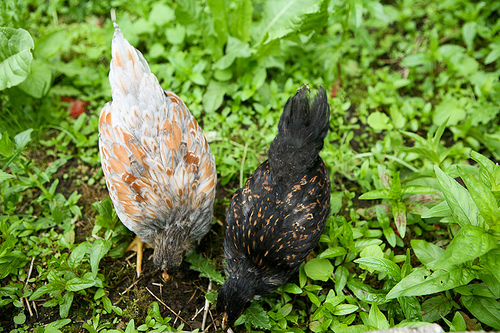<image>
Can you confirm if the hen is on the grass? Yes. Looking at the image, I can see the hen is positioned on top of the grass, with the grass providing support. Is there a bird next to the bird? Yes. The bird is positioned adjacent to the bird, located nearby in the same general area. 